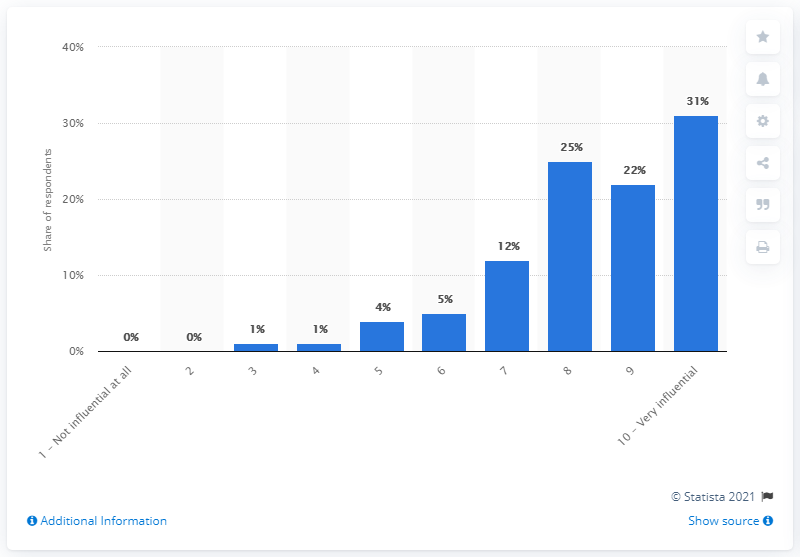Give some essential details in this illustration. Two consecutive scale points, 6 and 7, have a difference of 7%. The scale with the highest share is 10.. 